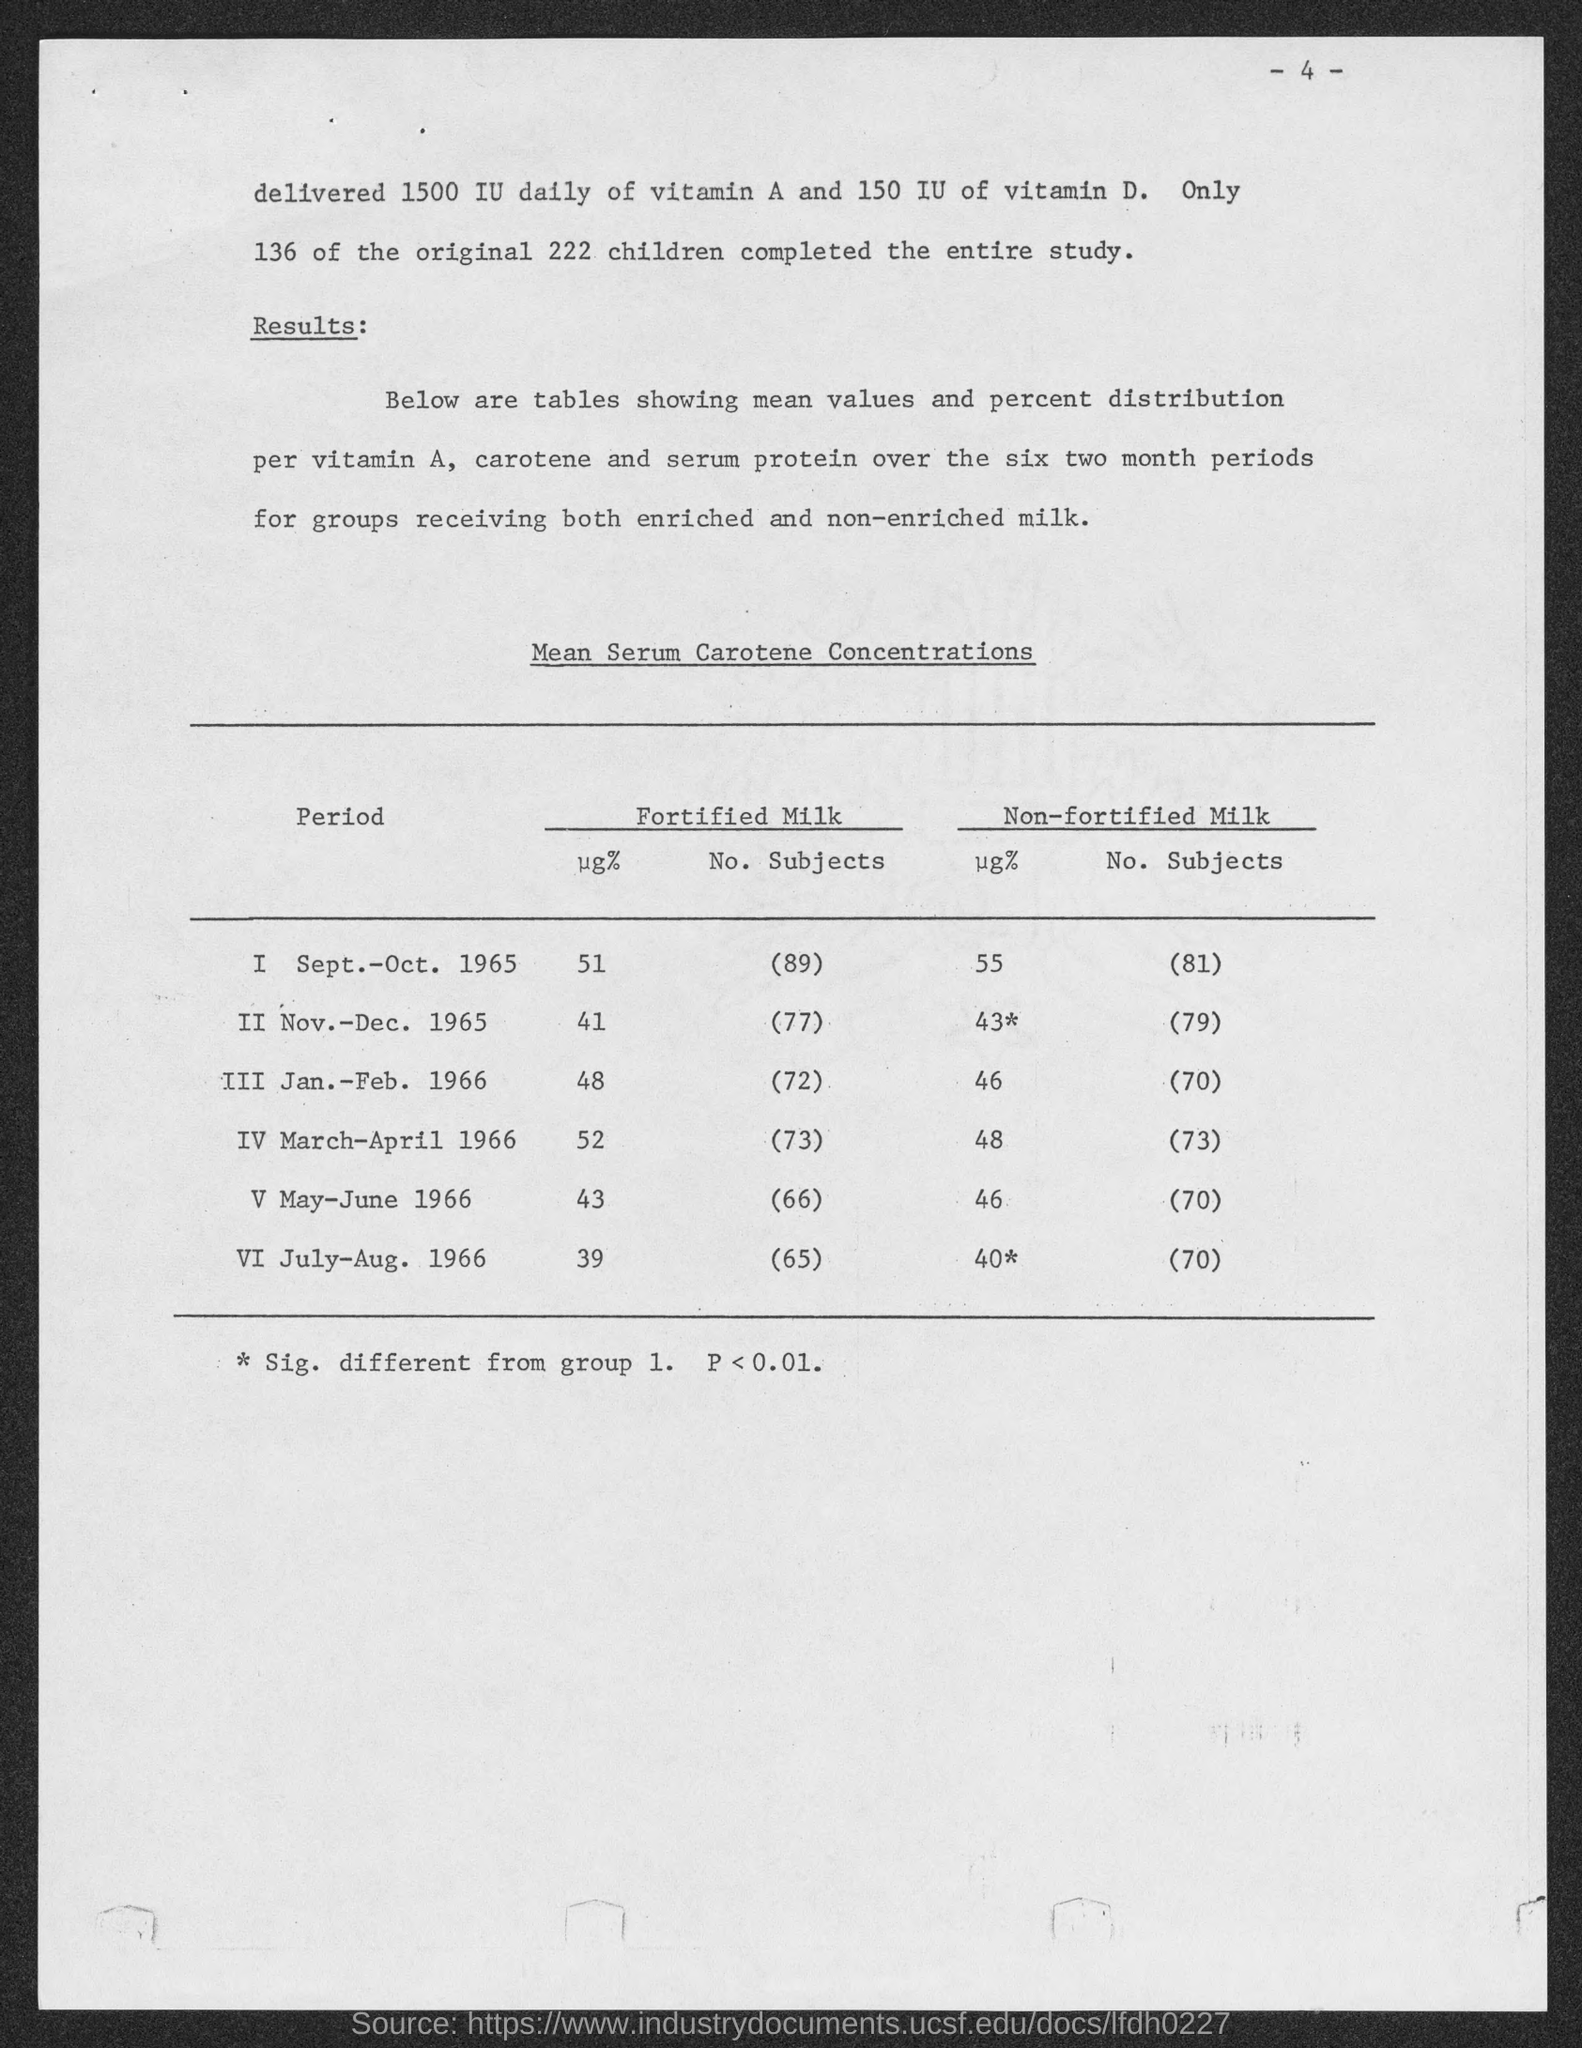Specify some key components in this picture. The number of subjects who had fortified milk during the period of September-October 1965 was 89. There were 81 subjects who consumed non-fortified milk during the period of September-October 1965. Out of the total number of children participating in the study, 136 completed the entire study. The total number of children was 222. 